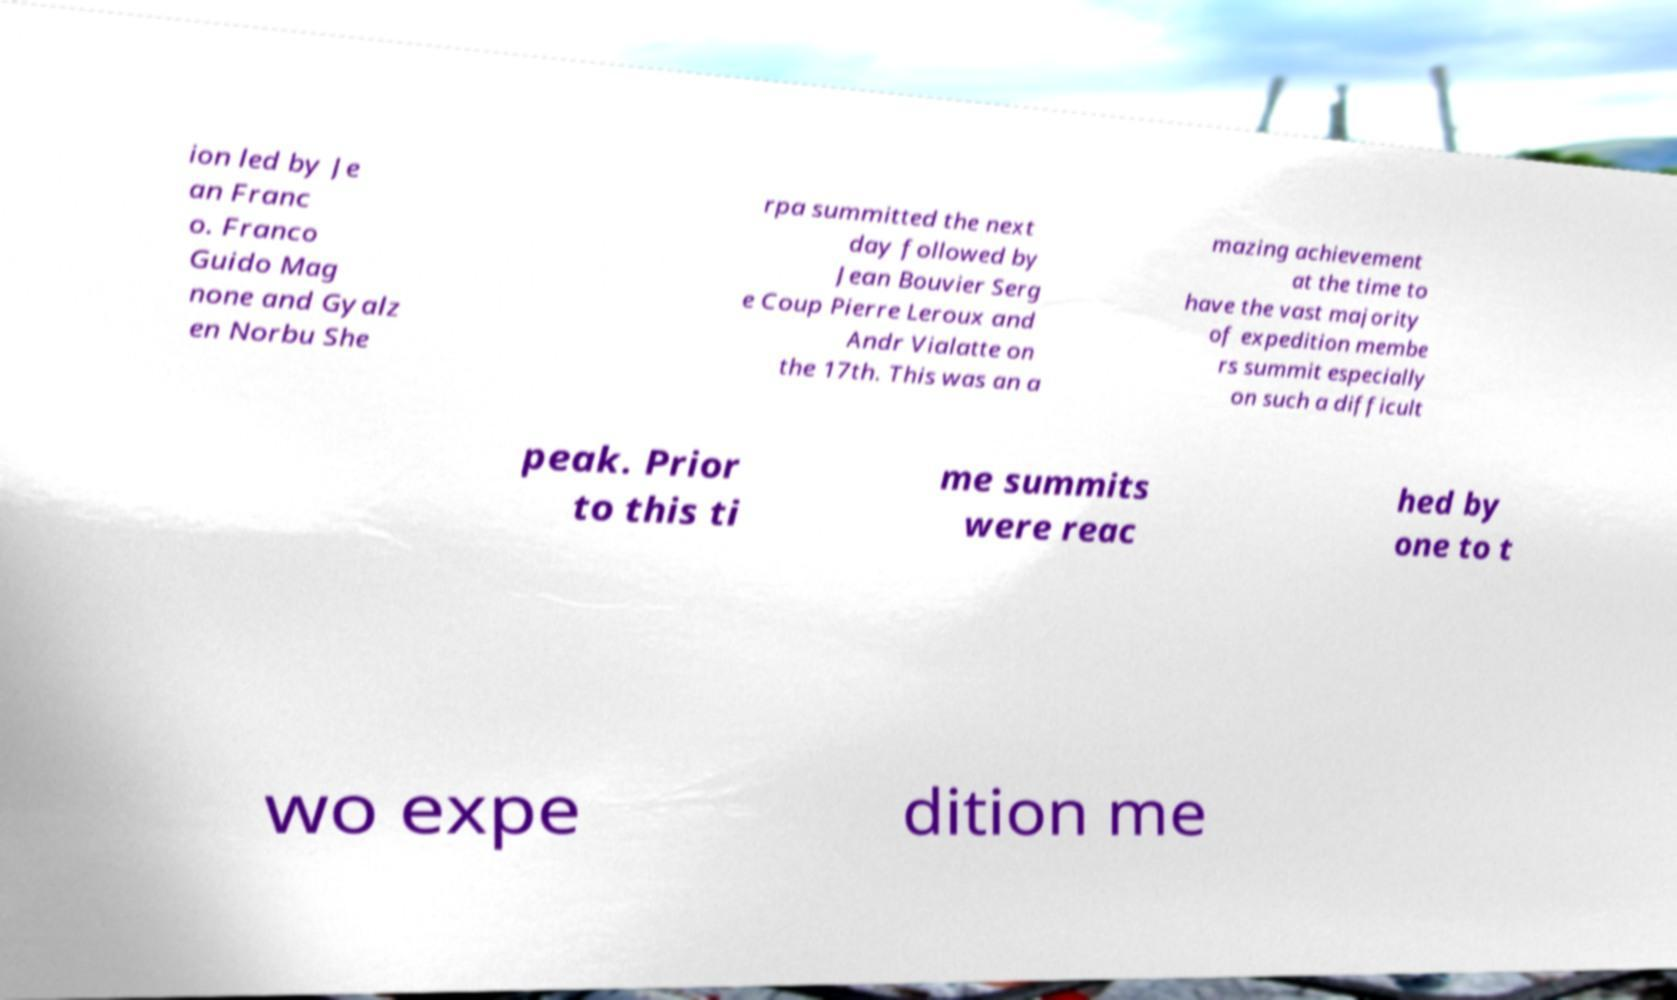Please read and relay the text visible in this image. What does it say? ion led by Je an Franc o. Franco Guido Mag none and Gyalz en Norbu She rpa summitted the next day followed by Jean Bouvier Serg e Coup Pierre Leroux and Andr Vialatte on the 17th. This was an a mazing achievement at the time to have the vast majority of expedition membe rs summit especially on such a difficult peak. Prior to this ti me summits were reac hed by one to t wo expe dition me 